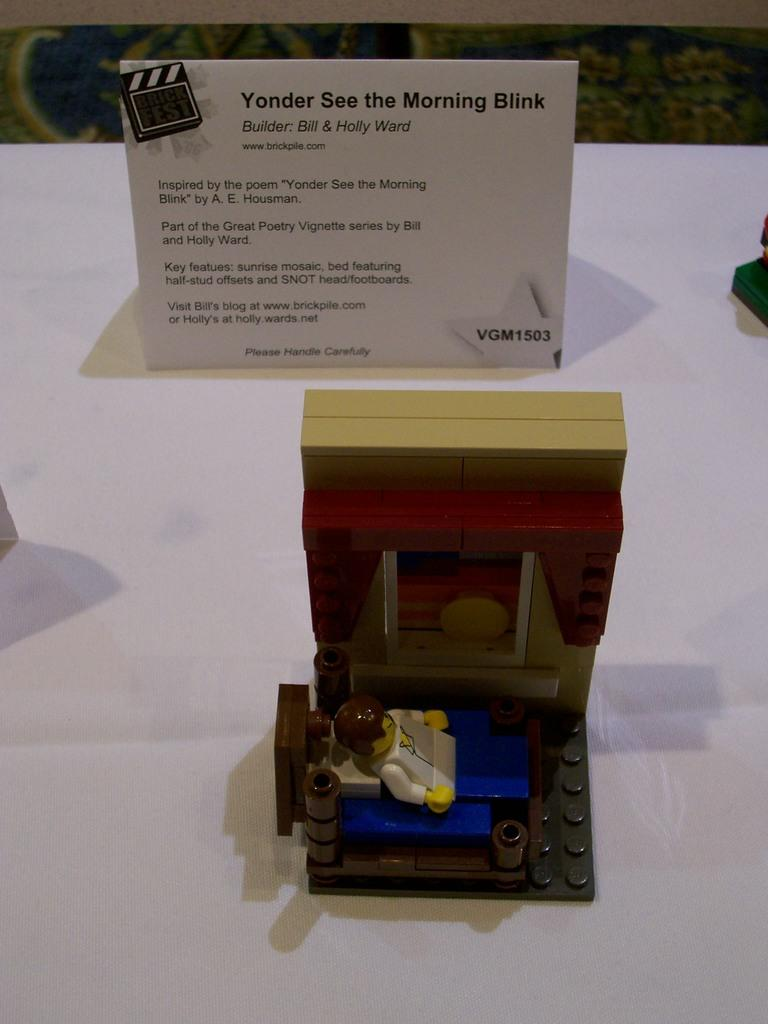<image>
Present a compact description of the photo's key features. Lego creation of a person in bed named "Yonder See the Morning Blink". 